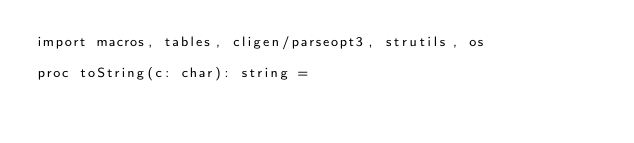<code> <loc_0><loc_0><loc_500><loc_500><_Nim_>import macros, tables, cligen/parseopt3, strutils, os

proc toString(c: char): string =</code> 